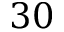<formula> <loc_0><loc_0><loc_500><loc_500>3 0</formula> 